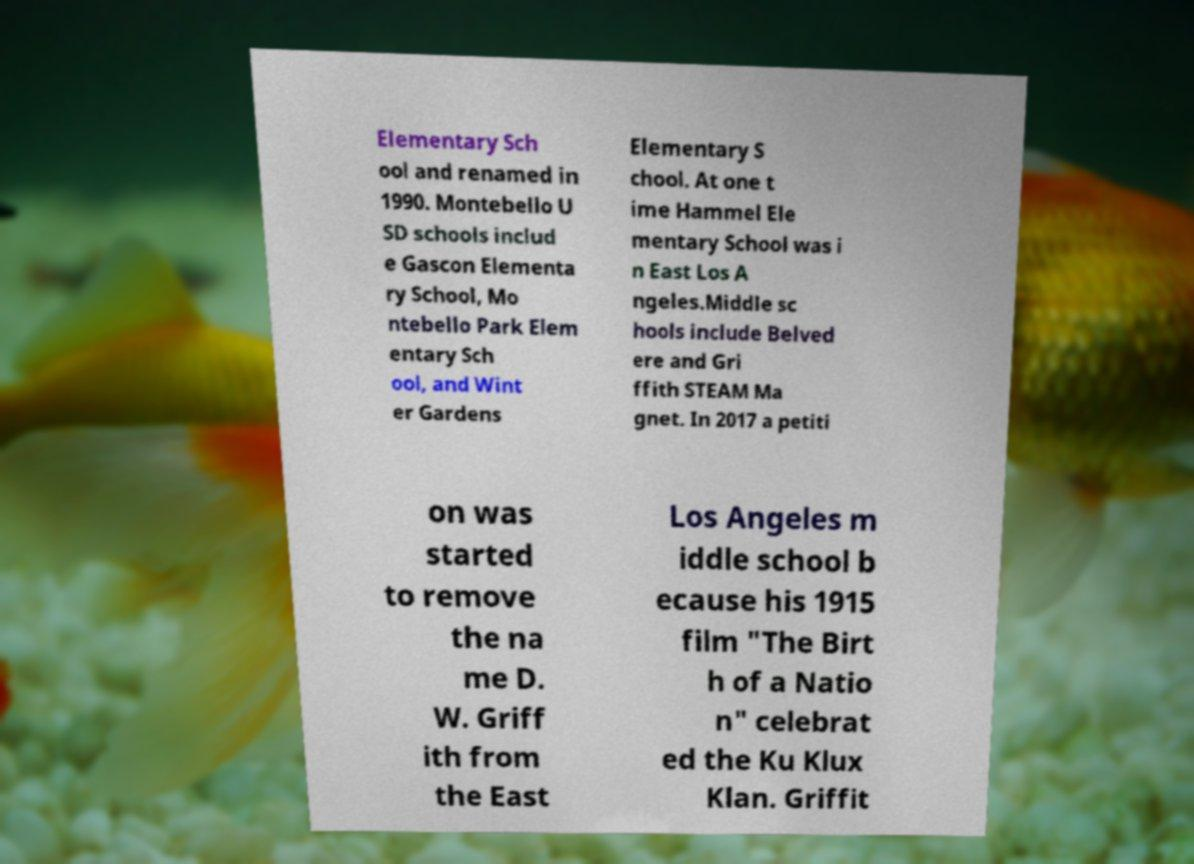Can you read and provide the text displayed in the image?This photo seems to have some interesting text. Can you extract and type it out for me? Elementary Sch ool and renamed in 1990. Montebello U SD schools includ e Gascon Elementa ry School, Mo ntebello Park Elem entary Sch ool, and Wint er Gardens Elementary S chool. At one t ime Hammel Ele mentary School was i n East Los A ngeles.Middle sc hools include Belved ere and Gri ffith STEAM Ma gnet. In 2017 a petiti on was started to remove the na me D. W. Griff ith from the East Los Angeles m iddle school b ecause his 1915 film "The Birt h of a Natio n" celebrat ed the Ku Klux Klan. Griffit 